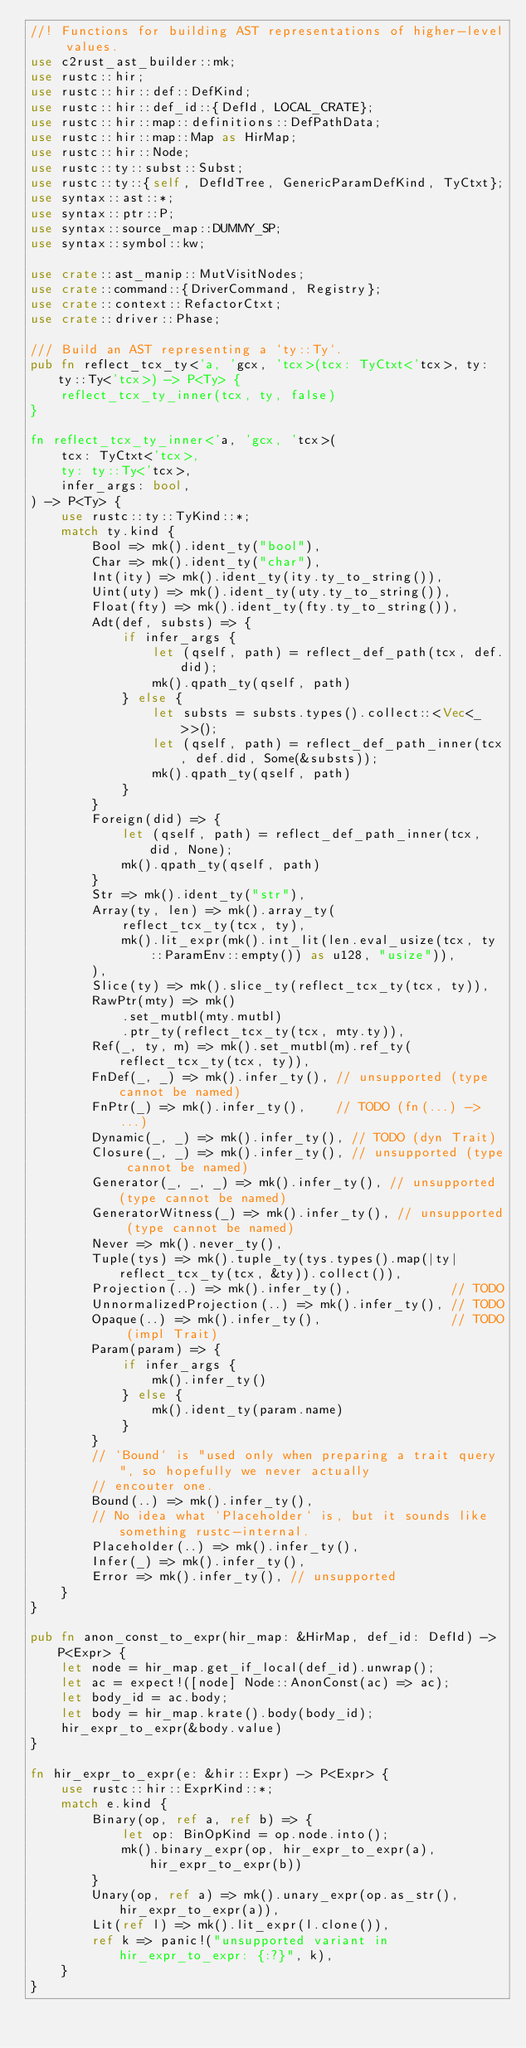Convert code to text. <code><loc_0><loc_0><loc_500><loc_500><_Rust_>//! Functions for building AST representations of higher-level values.
use c2rust_ast_builder::mk;
use rustc::hir;
use rustc::hir::def::DefKind;
use rustc::hir::def_id::{DefId, LOCAL_CRATE};
use rustc::hir::map::definitions::DefPathData;
use rustc::hir::map::Map as HirMap;
use rustc::hir::Node;
use rustc::ty::subst::Subst;
use rustc::ty::{self, DefIdTree, GenericParamDefKind, TyCtxt};
use syntax::ast::*;
use syntax::ptr::P;
use syntax::source_map::DUMMY_SP;
use syntax::symbol::kw;

use crate::ast_manip::MutVisitNodes;
use crate::command::{DriverCommand, Registry};
use crate::context::RefactorCtxt;
use crate::driver::Phase;

/// Build an AST representing a `ty::Ty`.
pub fn reflect_tcx_ty<'a, 'gcx, 'tcx>(tcx: TyCtxt<'tcx>, ty: ty::Ty<'tcx>) -> P<Ty> {
    reflect_tcx_ty_inner(tcx, ty, false)
}

fn reflect_tcx_ty_inner<'a, 'gcx, 'tcx>(
    tcx: TyCtxt<'tcx>,
    ty: ty::Ty<'tcx>,
    infer_args: bool,
) -> P<Ty> {
    use rustc::ty::TyKind::*;
    match ty.kind {
        Bool => mk().ident_ty("bool"),
        Char => mk().ident_ty("char"),
        Int(ity) => mk().ident_ty(ity.ty_to_string()),
        Uint(uty) => mk().ident_ty(uty.ty_to_string()),
        Float(fty) => mk().ident_ty(fty.ty_to_string()),
        Adt(def, substs) => {
            if infer_args {
                let (qself, path) = reflect_def_path(tcx, def.did);
                mk().qpath_ty(qself, path)
            } else {
                let substs = substs.types().collect::<Vec<_>>();
                let (qself, path) = reflect_def_path_inner(tcx, def.did, Some(&substs));
                mk().qpath_ty(qself, path)
            }
        }
        Foreign(did) => {
            let (qself, path) = reflect_def_path_inner(tcx, did, None);
            mk().qpath_ty(qself, path)
        }
        Str => mk().ident_ty("str"),
        Array(ty, len) => mk().array_ty(
            reflect_tcx_ty(tcx, ty),
            mk().lit_expr(mk().int_lit(len.eval_usize(tcx, ty::ParamEnv::empty()) as u128, "usize")),
        ),
        Slice(ty) => mk().slice_ty(reflect_tcx_ty(tcx, ty)),
        RawPtr(mty) => mk()
            .set_mutbl(mty.mutbl)
            .ptr_ty(reflect_tcx_ty(tcx, mty.ty)),
        Ref(_, ty, m) => mk().set_mutbl(m).ref_ty(reflect_tcx_ty(tcx, ty)),
        FnDef(_, _) => mk().infer_ty(), // unsupported (type cannot be named)
        FnPtr(_) => mk().infer_ty(),    // TODO (fn(...) -> ...)
        Dynamic(_, _) => mk().infer_ty(), // TODO (dyn Trait)
        Closure(_, _) => mk().infer_ty(), // unsupported (type cannot be named)
        Generator(_, _, _) => mk().infer_ty(), // unsupported (type cannot be named)
        GeneratorWitness(_) => mk().infer_ty(), // unsupported (type cannot be named)
        Never => mk().never_ty(),
        Tuple(tys) => mk().tuple_ty(tys.types().map(|ty| reflect_tcx_ty(tcx, &ty)).collect()),
        Projection(..) => mk().infer_ty(),             // TODO
        UnnormalizedProjection(..) => mk().infer_ty(), // TODO
        Opaque(..) => mk().infer_ty(),                 // TODO (impl Trait)
        Param(param) => {
            if infer_args {
                mk().infer_ty()
            } else {
                mk().ident_ty(param.name)
            }
        }
        // `Bound` is "used only when preparing a trait query", so hopefully we never actually
        // encouter one.
        Bound(..) => mk().infer_ty(),
        // No idea what `Placeholder` is, but it sounds like something rustc-internal.
        Placeholder(..) => mk().infer_ty(),
        Infer(_) => mk().infer_ty(),
        Error => mk().infer_ty(), // unsupported
    }
}

pub fn anon_const_to_expr(hir_map: &HirMap, def_id: DefId) -> P<Expr> {
    let node = hir_map.get_if_local(def_id).unwrap();
    let ac = expect!([node] Node::AnonConst(ac) => ac);
    let body_id = ac.body;
    let body = hir_map.krate().body(body_id);
    hir_expr_to_expr(&body.value)
}

fn hir_expr_to_expr(e: &hir::Expr) -> P<Expr> {
    use rustc::hir::ExprKind::*;
    match e.kind {
        Binary(op, ref a, ref b) => {
            let op: BinOpKind = op.node.into();
            mk().binary_expr(op, hir_expr_to_expr(a), hir_expr_to_expr(b))
        }
        Unary(op, ref a) => mk().unary_expr(op.as_str(), hir_expr_to_expr(a)),
        Lit(ref l) => mk().lit_expr(l.clone()),
        ref k => panic!("unsupported variant in hir_expr_to_expr: {:?}", k),
    }
}
</code> 